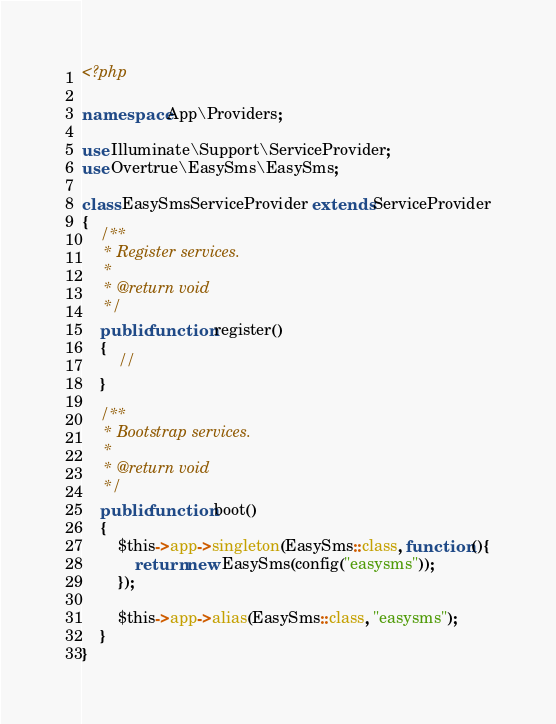<code> <loc_0><loc_0><loc_500><loc_500><_PHP_><?php

namespace App\Providers;

use Illuminate\Support\ServiceProvider;
use Overtrue\EasySms\EasySms;

class EasySmsServiceProvider extends ServiceProvider
{
    /**
     * Register services.
     *
     * @return void
     */
    public function register()
    {
        //
    }

    /**
     * Bootstrap services.
     *
     * @return void
     */
    public function boot()
    {
        $this->app->singleton(EasySms::class, function (){
            return new EasySms(config("easysms"));
        });

        $this->app->alias(EasySms::class, "easysms");
    }
}
</code> 